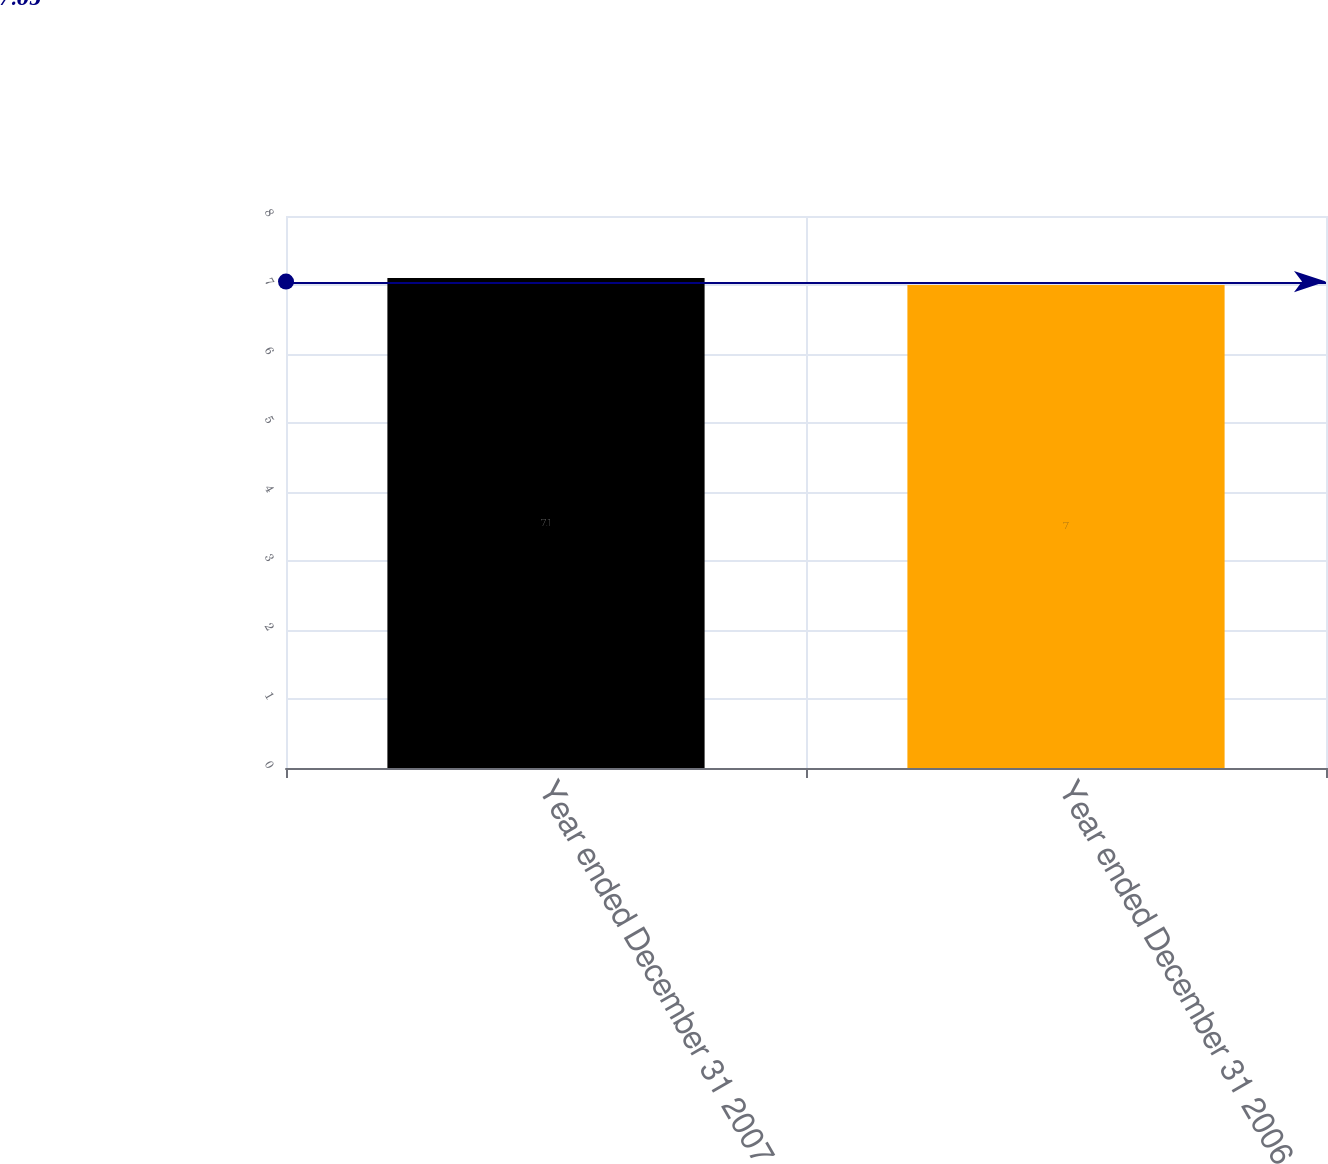Convert chart. <chart><loc_0><loc_0><loc_500><loc_500><bar_chart><fcel>Year ended December 31 2007<fcel>Year ended December 31 2006<nl><fcel>7.1<fcel>7<nl></chart> 